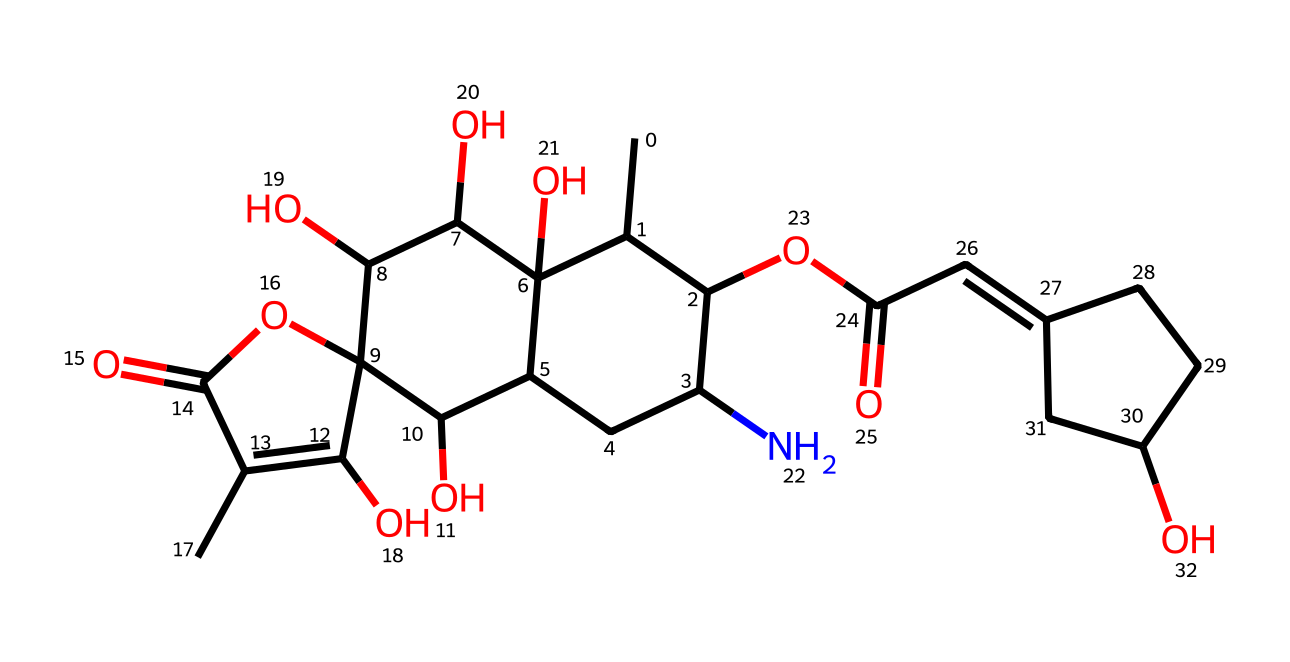What is the total number of carbon atoms in batrachotoxin? By examining the SMILES representation, I count the number of 'C' characters. Each represents a carbon atom in the structure. After counting carefully, I find there are 27 carbon atoms.
Answer: 27 How many hydroxyl (-OH) groups are present in this structure? The presence of hydroxyl groups can be identified by finding 'O' in the structure followed by hydrogen connections. Upon closer inspection, I can identify 4 hydroxyl (-OH) groups linked to different carbon atoms.
Answer: 4 What type of functional groups are represented in batrachotoxin? By analyzing the structure, I note that functional groups include carbonyl (=O), carboxylic acid (-COOH), and hydroxyl (-OH) groups. Batrachotoxin contains these diverse groups that contribute to its properties.
Answer: carbonyl, carboxylic acid, hydroxyl What is the degree of unsaturation in batrachotoxin? The degree of unsaturation can be calculated by considering the number of rings and multiple bonds present in the molecule. From analysis, I see there are 2 rings and multiple double bonds present, providing a degree of unsaturation of 5.
Answer: 5 How many nitrogen atoms are present in batrachotoxin? I can identify nitrogen in the SMILES representation, denoted by 'N'. Counting them reveals that 1 nitrogen atom is present in this molecule, which is crucial for its neurotoxic properties.
Answer: 1 